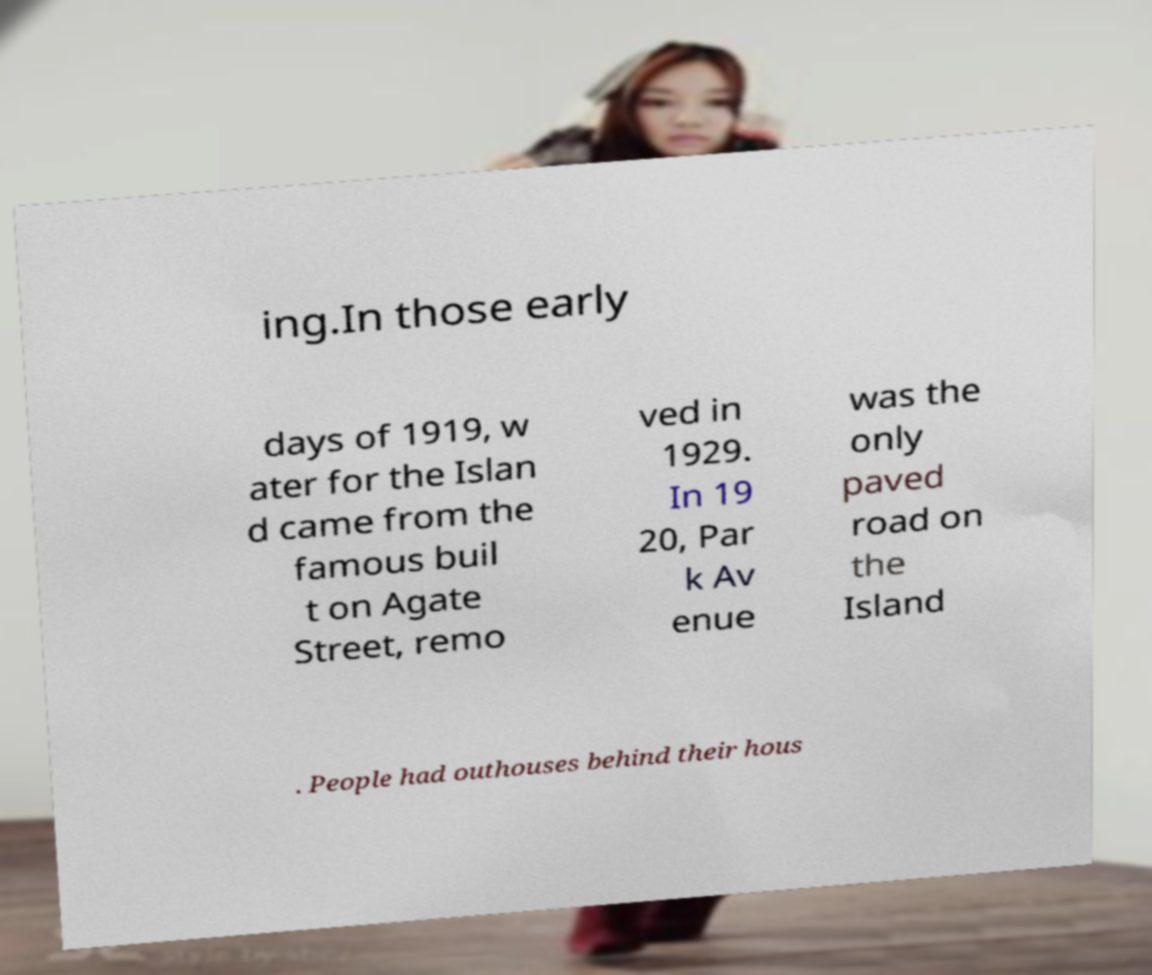For documentation purposes, I need the text within this image transcribed. Could you provide that? ing.In those early days of 1919, w ater for the Islan d came from the famous buil t on Agate Street, remo ved in 1929. In 19 20, Par k Av enue was the only paved road on the Island . People had outhouses behind their hous 